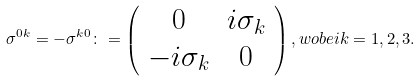Convert formula to latex. <formula><loc_0><loc_0><loc_500><loc_500>\sigma ^ { 0 k } = - \sigma ^ { k 0 } \colon = \left ( \begin{array} { * { 2 } { c } } 0 & i \sigma _ { k } \\ - i \sigma _ { k } & 0 \end{array} \right ) , w o b e i k = 1 , 2 , 3 .</formula> 